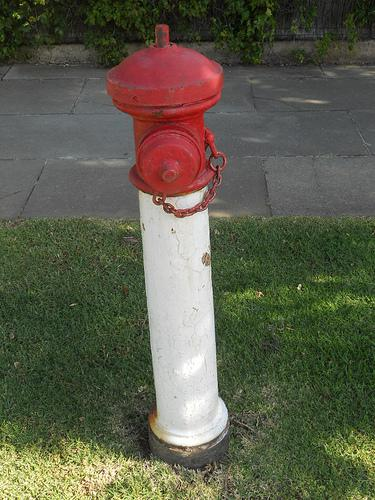Question: what is the color of the fire hydrant?
Choices:
A. Yellow.
B. Red.
C. High visibility green.
D. White and red.
Answer with the letter. Answer: D Question: what is the color of the grass?
Choices:
A. Blue.
B. Green.
C. Yellow.
D. Orange.
Answer with the letter. Answer: B Question: what is the sidewalk made of?
Choices:
A. Cement.
B. Granite.
C. Concrete.
D. Glass.
Answer with the letter. Answer: A Question: who is walking on the sidewalk?
Choices:
A. 2 people.
B. A group of people.
C. No one.
D. 1 person.
Answer with the letter. Answer: C 